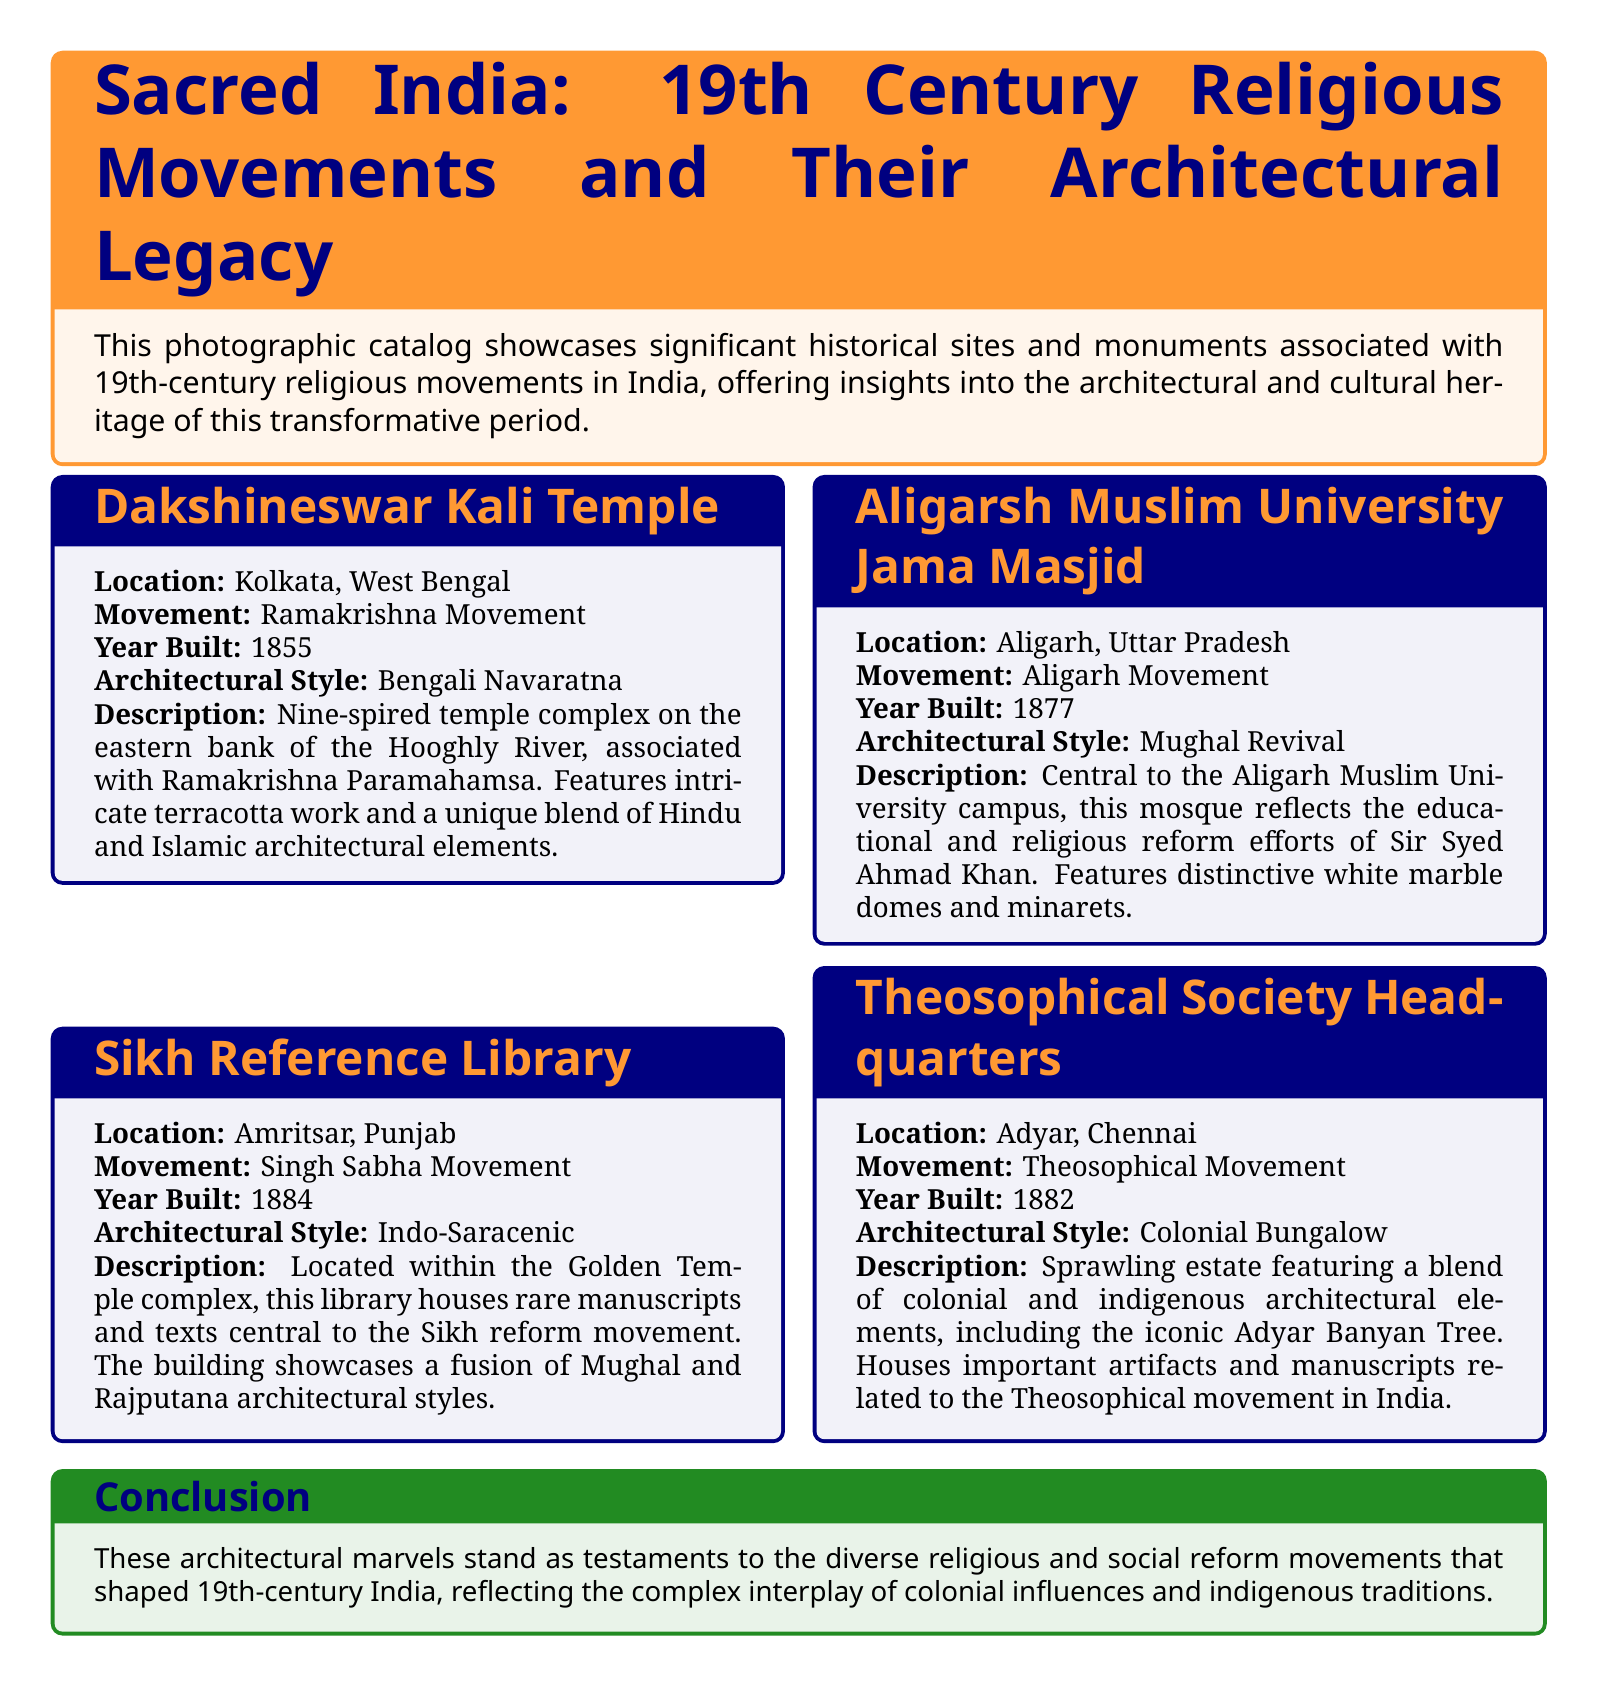What is the location of the Dakshineswar Kali Temple? The location provided in the document indicates that the Dakshineswar Kali Temple is situated in Kolkata, West Bengal.
Answer: Kolkata, West Bengal Which religious movement is associated with the Aligarsh Muslim University Jama Masjid? The document explicitly states that the Aligarsh Muslim University Jama Masjid is associated with the Aligarh Movement.
Answer: Aligarh Movement What architectural style is showcased by the Sikh Reference Library? According to the document, the architectural style of the Sikh Reference Library is Indo-Saracenic.
Answer: Indo-Saracenic In what year was Theosophical Society Headquarters built? The document provides the year built for Theosophical Society Headquarters as 1882.
Answer: 1882 What notable feature does the Dakshineswar Kali Temple have? The description notes that the Dakshineswar Kali Temple features a unique blend of Hindu and Islamic architectural elements.
Answer: Unique blend of Hindu and Islamic architectural elements How many spires does the Dakshineswar Kali Temple complex have? The document describes the temple complex as a nine-spired temple.
Answer: Nine-spired What is the central purpose of the Sikh Reference Library? The document states that the Sikh Reference Library houses rare manuscripts and texts central to the Sikh reform movement.
Answer: Rare manuscripts and texts central to the Sikh reform movement Which architectural elements are highlighted in the Theosophical Society Headquarters? The document highlights a blend of colonial and indigenous architectural elements, including the iconic Adyar Banyan Tree.
Answer: Colonial and indigenous architectural elements What is the conclusion regarding the architectural sites mentioned in the catalog? The conclusion summarizes that these architectural marvels reflect the complex interplay of colonial influences and indigenous traditions through religious and social reform movements.
Answer: Interplay of colonial influences and indigenous traditions 